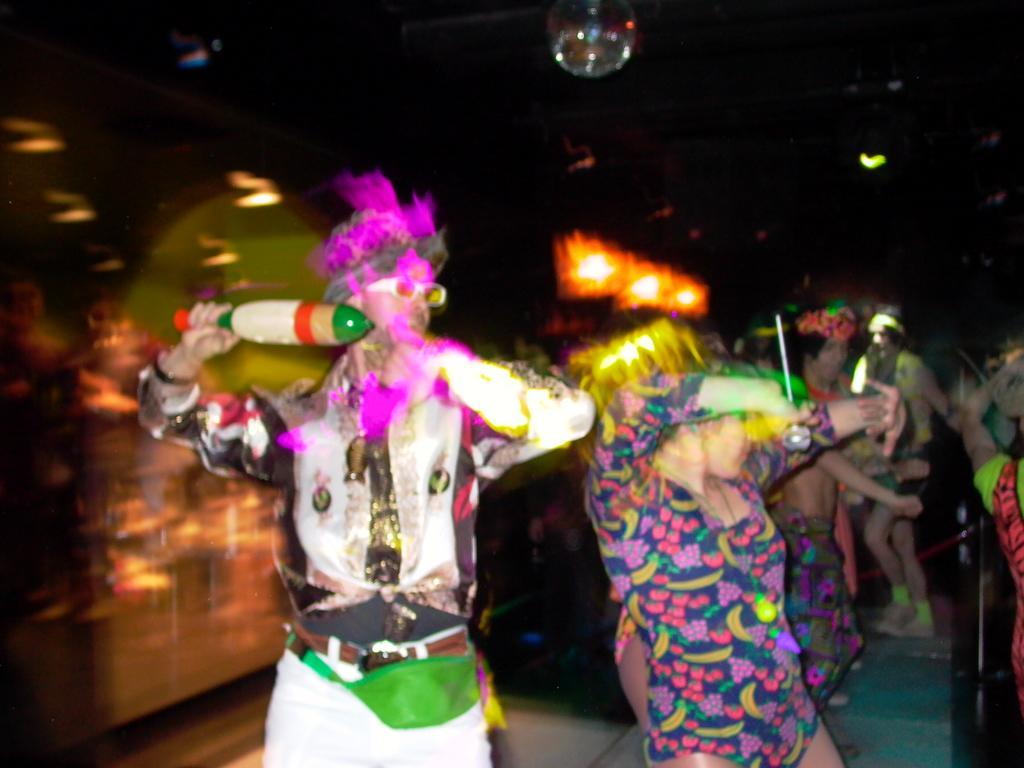How would you summarize this image in a sentence or two? In this image there are group of people who are wearing some costumes and dancing, and in the background there are some lights and some objects. At the top of the image there is light, and at the bottom there is floor. 